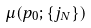<formula> <loc_0><loc_0><loc_500><loc_500>\mu ( p _ { 0 } ; \{ j _ { N } \} )</formula> 